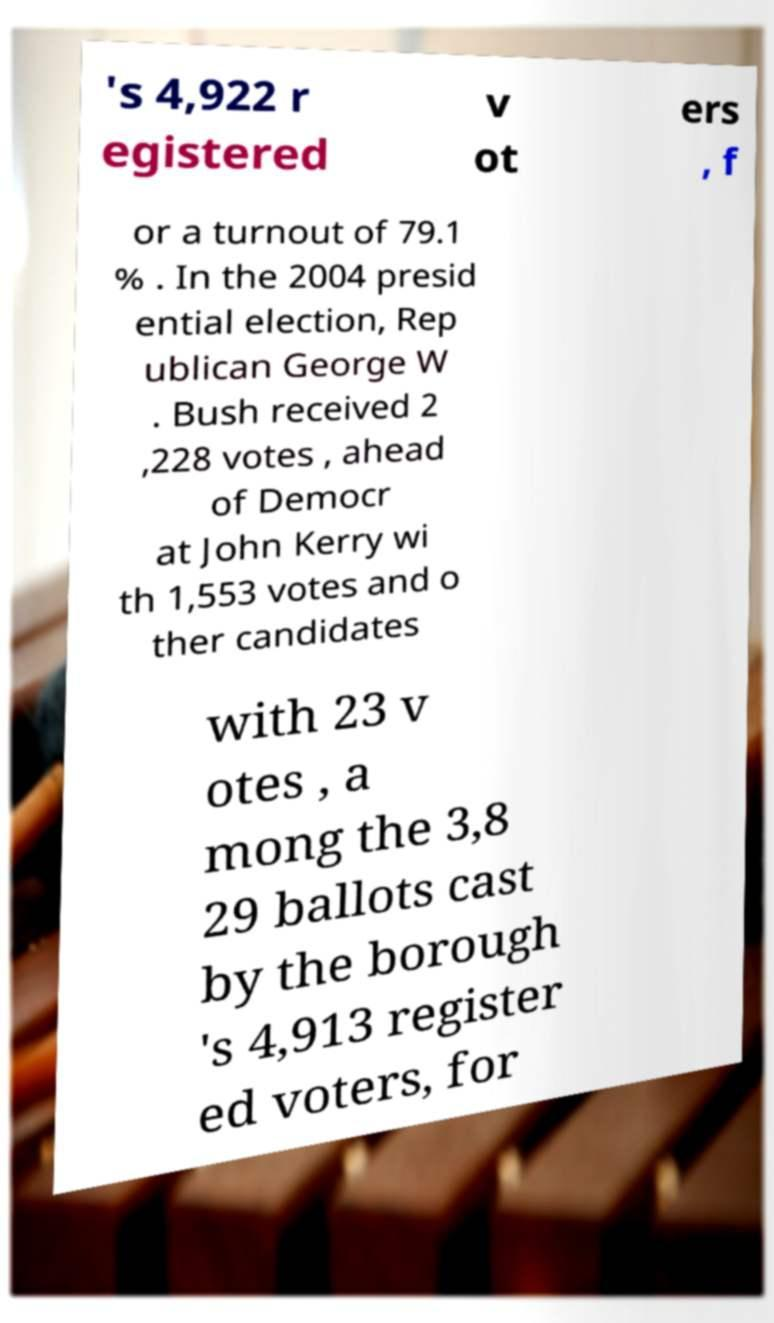What messages or text are displayed in this image? I need them in a readable, typed format. 's 4,922 r egistered v ot ers , f or a turnout of 79.1 % . In the 2004 presid ential election, Rep ublican George W . Bush received 2 ,228 votes , ahead of Democr at John Kerry wi th 1,553 votes and o ther candidates with 23 v otes , a mong the 3,8 29 ballots cast by the borough 's 4,913 register ed voters, for 